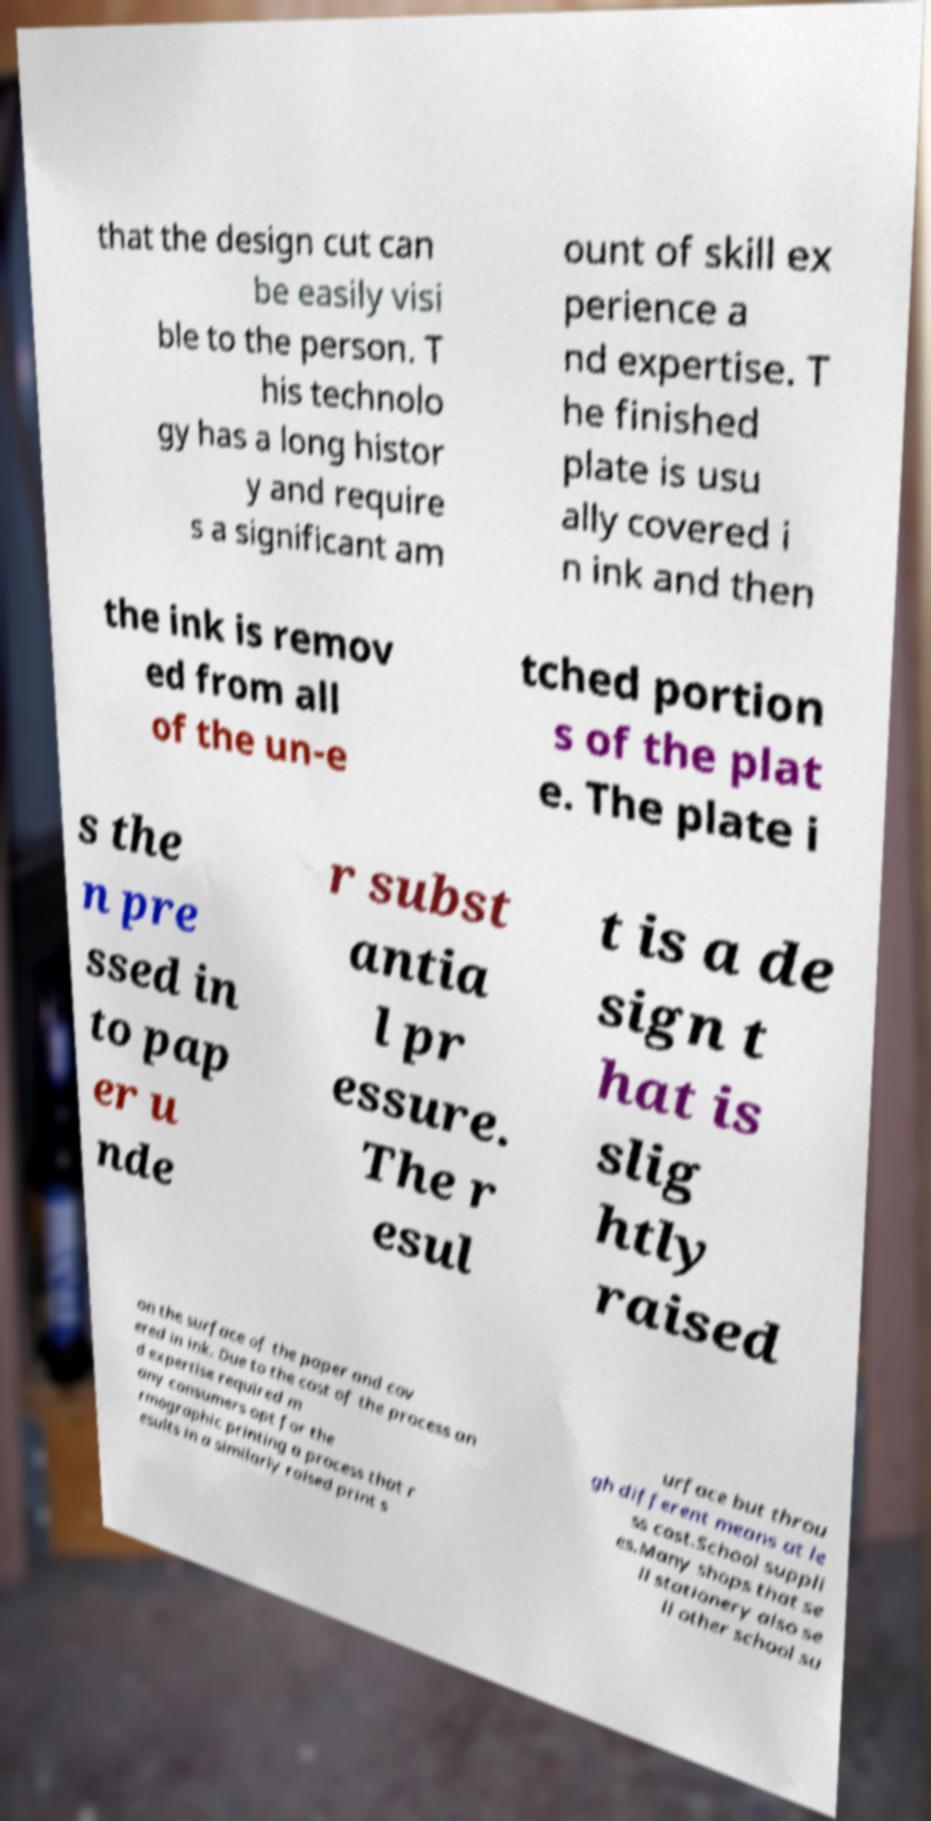I need the written content from this picture converted into text. Can you do that? that the design cut can be easily visi ble to the person. T his technolo gy has a long histor y and require s a significant am ount of skill ex perience a nd expertise. T he finished plate is usu ally covered i n ink and then the ink is remov ed from all of the un-e tched portion s of the plat e. The plate i s the n pre ssed in to pap er u nde r subst antia l pr essure. The r esul t is a de sign t hat is slig htly raised on the surface of the paper and cov ered in ink. Due to the cost of the process an d expertise required m any consumers opt for the rmographic printing a process that r esults in a similarly raised print s urface but throu gh different means at le ss cost.School suppli es.Many shops that se ll stationery also se ll other school su 